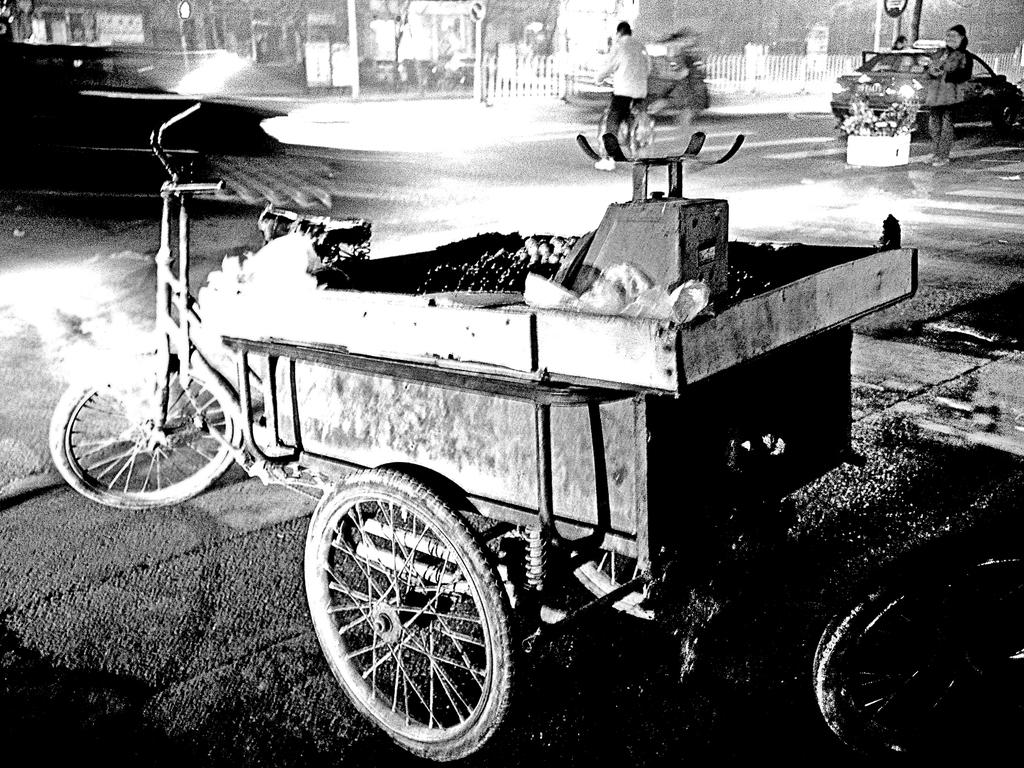What is the color scheme of the image? The image is black and white. What mode of transportation can be seen in the image? There is a rickshaw in the image. What type of vehicles are present on the road in the image? There are cars on a road in the image. How many people are visible in the image? There are two persons in the image. What type of health issues are the persons in the image discussing? There is no indication of a discussion or any health issues in the image. Can you tell me how many jelly beans are on the rickshaw in the image? There are no jelly beans present in the image; it features a rickshaw and cars on a road. 